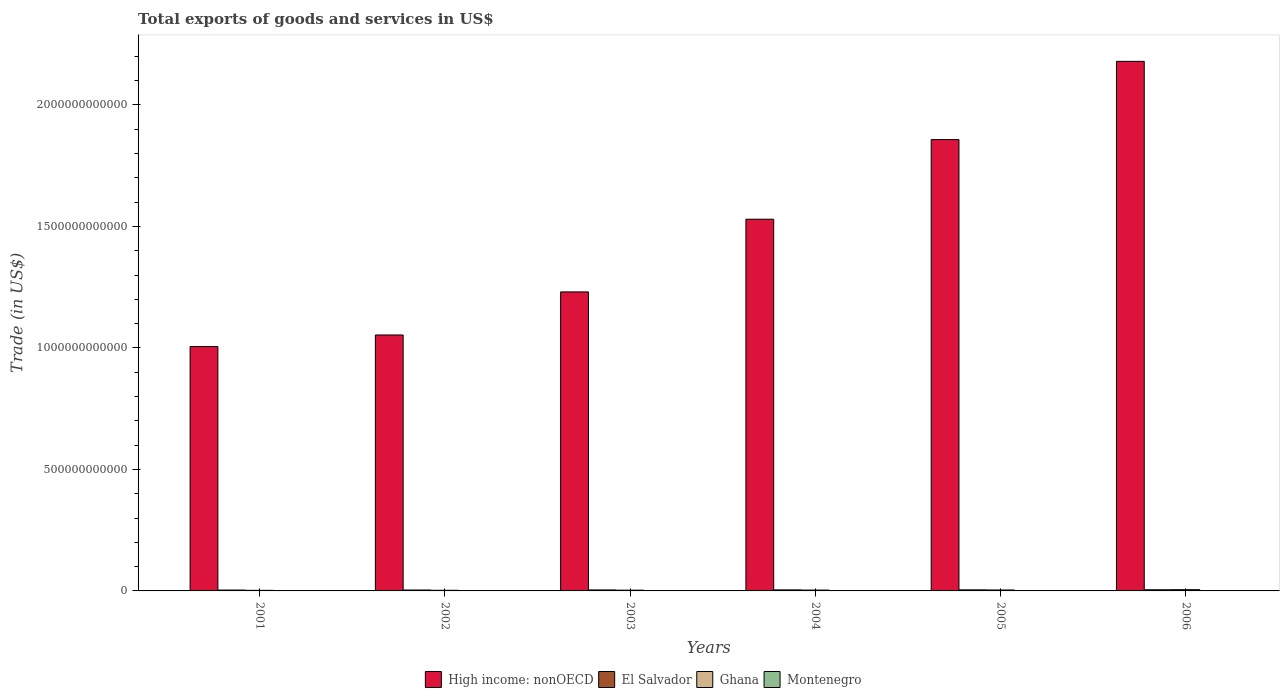How many different coloured bars are there?
Your answer should be compact. 4. Are the number of bars per tick equal to the number of legend labels?
Give a very brief answer. Yes. How many bars are there on the 1st tick from the right?
Keep it short and to the point. 4. What is the label of the 4th group of bars from the left?
Keep it short and to the point. 2004. What is the total exports of goods and services in Ghana in 2003?
Keep it short and to the point. 3.10e+09. Across all years, what is the maximum total exports of goods and services in Montenegro?
Your answer should be compact. 1.33e+09. Across all years, what is the minimum total exports of goods and services in High income: nonOECD?
Provide a succinct answer. 1.01e+12. What is the total total exports of goods and services in High income: nonOECD in the graph?
Provide a short and direct response. 8.86e+12. What is the difference between the total exports of goods and services in El Salvador in 2004 and that in 2006?
Give a very brief answer. -5.05e+08. What is the difference between the total exports of goods and services in El Salvador in 2006 and the total exports of goods and services in High income: nonOECD in 2002?
Give a very brief answer. -1.05e+12. What is the average total exports of goods and services in Montenegro per year?
Your answer should be compact. 7.68e+08. In the year 2003, what is the difference between the total exports of goods and services in High income: nonOECD and total exports of goods and services in Ghana?
Your answer should be compact. 1.23e+12. What is the ratio of the total exports of goods and services in Ghana in 2002 to that in 2004?
Provide a short and direct response. 0.75. What is the difference between the highest and the second highest total exports of goods and services in Ghana?
Keep it short and to the point. 1.23e+09. What is the difference between the highest and the lowest total exports of goods and services in Montenegro?
Provide a short and direct response. 8.85e+08. Is the sum of the total exports of goods and services in High income: nonOECD in 2003 and 2005 greater than the maximum total exports of goods and services in Montenegro across all years?
Ensure brevity in your answer.  Yes. What does the 1st bar from the left in 2003 represents?
Ensure brevity in your answer.  High income: nonOECD. What does the 4th bar from the right in 2004 represents?
Make the answer very short. High income: nonOECD. Is it the case that in every year, the sum of the total exports of goods and services in High income: nonOECD and total exports of goods and services in Montenegro is greater than the total exports of goods and services in Ghana?
Offer a very short reply. Yes. How many bars are there?
Keep it short and to the point. 24. Are all the bars in the graph horizontal?
Offer a terse response. No. What is the difference between two consecutive major ticks on the Y-axis?
Provide a succinct answer. 5.00e+11. Are the values on the major ticks of Y-axis written in scientific E-notation?
Make the answer very short. No. Does the graph contain any zero values?
Offer a very short reply. No. Does the graph contain grids?
Offer a terse response. No. How many legend labels are there?
Your response must be concise. 4. What is the title of the graph?
Make the answer very short. Total exports of goods and services in US$. What is the label or title of the Y-axis?
Your response must be concise. Trade (in US$). What is the Trade (in US$) of High income: nonOECD in 2001?
Your response must be concise. 1.01e+12. What is the Trade (in US$) in El Salvador in 2001?
Make the answer very short. 3.57e+09. What is the Trade (in US$) in Ghana in 2001?
Your answer should be very brief. 2.40e+09. What is the Trade (in US$) of Montenegro in 2001?
Your response must be concise. 4.46e+08. What is the Trade (in US$) in High income: nonOECD in 2002?
Offer a terse response. 1.05e+12. What is the Trade (in US$) in El Salvador in 2002?
Keep it short and to the point. 3.77e+09. What is the Trade (in US$) of Ghana in 2002?
Offer a terse response. 2.63e+09. What is the Trade (in US$) of Montenegro in 2002?
Provide a succinct answer. 4.54e+08. What is the Trade (in US$) in High income: nonOECD in 2003?
Your response must be concise. 1.23e+12. What is the Trade (in US$) of El Salvador in 2003?
Your answer should be compact. 4.07e+09. What is the Trade (in US$) of Ghana in 2003?
Ensure brevity in your answer.  3.10e+09. What is the Trade (in US$) in Montenegro in 2003?
Keep it short and to the point. 5.23e+08. What is the Trade (in US$) in High income: nonOECD in 2004?
Make the answer very short. 1.53e+12. What is the Trade (in US$) in El Salvador in 2004?
Provide a succinct answer. 4.26e+09. What is the Trade (in US$) in Ghana in 2004?
Offer a terse response. 3.49e+09. What is the Trade (in US$) in Montenegro in 2004?
Your response must be concise. 8.71e+08. What is the Trade (in US$) of High income: nonOECD in 2005?
Ensure brevity in your answer.  1.86e+12. What is the Trade (in US$) of El Salvador in 2005?
Your answer should be compact. 4.38e+09. What is the Trade (in US$) of Ghana in 2005?
Your answer should be compact. 3.91e+09. What is the Trade (in US$) of Montenegro in 2005?
Your response must be concise. 9.83e+08. What is the Trade (in US$) in High income: nonOECD in 2006?
Your answer should be compact. 2.18e+12. What is the Trade (in US$) of El Salvador in 2006?
Keep it short and to the point. 4.76e+09. What is the Trade (in US$) in Ghana in 2006?
Keep it short and to the point. 5.14e+09. What is the Trade (in US$) in Montenegro in 2006?
Provide a short and direct response. 1.33e+09. Across all years, what is the maximum Trade (in US$) of High income: nonOECD?
Give a very brief answer. 2.18e+12. Across all years, what is the maximum Trade (in US$) in El Salvador?
Offer a very short reply. 4.76e+09. Across all years, what is the maximum Trade (in US$) in Ghana?
Offer a terse response. 5.14e+09. Across all years, what is the maximum Trade (in US$) in Montenegro?
Give a very brief answer. 1.33e+09. Across all years, what is the minimum Trade (in US$) of High income: nonOECD?
Your answer should be very brief. 1.01e+12. Across all years, what is the minimum Trade (in US$) of El Salvador?
Your answer should be very brief. 3.57e+09. Across all years, what is the minimum Trade (in US$) of Ghana?
Offer a very short reply. 2.40e+09. Across all years, what is the minimum Trade (in US$) in Montenegro?
Make the answer very short. 4.46e+08. What is the total Trade (in US$) of High income: nonOECD in the graph?
Keep it short and to the point. 8.86e+12. What is the total Trade (in US$) in El Salvador in the graph?
Offer a terse response. 2.48e+1. What is the total Trade (in US$) in Ghana in the graph?
Your answer should be compact. 2.07e+1. What is the total Trade (in US$) of Montenegro in the graph?
Offer a very short reply. 4.61e+09. What is the difference between the Trade (in US$) in High income: nonOECD in 2001 and that in 2002?
Ensure brevity in your answer.  -4.76e+1. What is the difference between the Trade (in US$) of El Salvador in 2001 and that in 2002?
Make the answer very short. -2.04e+08. What is the difference between the Trade (in US$) of Ghana in 2001 and that in 2002?
Your answer should be very brief. -2.24e+08. What is the difference between the Trade (in US$) of Montenegro in 2001 and that in 2002?
Keep it short and to the point. -8.56e+06. What is the difference between the Trade (in US$) in High income: nonOECD in 2001 and that in 2003?
Offer a terse response. -2.25e+11. What is the difference between the Trade (in US$) of El Salvador in 2001 and that in 2003?
Give a very brief answer. -5.05e+08. What is the difference between the Trade (in US$) of Ghana in 2001 and that in 2003?
Offer a very short reply. -7.01e+08. What is the difference between the Trade (in US$) in Montenegro in 2001 and that in 2003?
Provide a succinct answer. -7.71e+07. What is the difference between the Trade (in US$) of High income: nonOECD in 2001 and that in 2004?
Provide a succinct answer. -5.24e+11. What is the difference between the Trade (in US$) in El Salvador in 2001 and that in 2004?
Offer a terse response. -6.91e+08. What is the difference between the Trade (in US$) of Ghana in 2001 and that in 2004?
Ensure brevity in your answer.  -1.09e+09. What is the difference between the Trade (in US$) in Montenegro in 2001 and that in 2004?
Make the answer very short. -4.26e+08. What is the difference between the Trade (in US$) in High income: nonOECD in 2001 and that in 2005?
Your answer should be very brief. -8.52e+11. What is the difference between the Trade (in US$) in El Salvador in 2001 and that in 2005?
Your answer should be compact. -8.15e+08. What is the difference between the Trade (in US$) in Ghana in 2001 and that in 2005?
Provide a short and direct response. -1.51e+09. What is the difference between the Trade (in US$) of Montenegro in 2001 and that in 2005?
Offer a very short reply. -5.37e+08. What is the difference between the Trade (in US$) of High income: nonOECD in 2001 and that in 2006?
Your response must be concise. -1.17e+12. What is the difference between the Trade (in US$) in El Salvador in 2001 and that in 2006?
Your response must be concise. -1.20e+09. What is the difference between the Trade (in US$) of Ghana in 2001 and that in 2006?
Offer a very short reply. -2.74e+09. What is the difference between the Trade (in US$) of Montenegro in 2001 and that in 2006?
Offer a terse response. -8.85e+08. What is the difference between the Trade (in US$) of High income: nonOECD in 2002 and that in 2003?
Offer a terse response. -1.77e+11. What is the difference between the Trade (in US$) of El Salvador in 2002 and that in 2003?
Your answer should be very brief. -3.01e+08. What is the difference between the Trade (in US$) in Ghana in 2002 and that in 2003?
Offer a very short reply. -4.77e+08. What is the difference between the Trade (in US$) of Montenegro in 2002 and that in 2003?
Your answer should be very brief. -6.85e+07. What is the difference between the Trade (in US$) in High income: nonOECD in 2002 and that in 2004?
Offer a very short reply. -4.76e+11. What is the difference between the Trade (in US$) in El Salvador in 2002 and that in 2004?
Make the answer very short. -4.87e+08. What is the difference between the Trade (in US$) of Ghana in 2002 and that in 2004?
Your answer should be compact. -8.63e+08. What is the difference between the Trade (in US$) of Montenegro in 2002 and that in 2004?
Offer a very short reply. -4.17e+08. What is the difference between the Trade (in US$) of High income: nonOECD in 2002 and that in 2005?
Provide a short and direct response. -8.04e+11. What is the difference between the Trade (in US$) in El Salvador in 2002 and that in 2005?
Offer a terse response. -6.11e+08. What is the difference between the Trade (in US$) in Ghana in 2002 and that in 2005?
Your answer should be very brief. -1.28e+09. What is the difference between the Trade (in US$) of Montenegro in 2002 and that in 2005?
Ensure brevity in your answer.  -5.29e+08. What is the difference between the Trade (in US$) of High income: nonOECD in 2002 and that in 2006?
Provide a short and direct response. -1.13e+12. What is the difference between the Trade (in US$) in El Salvador in 2002 and that in 2006?
Ensure brevity in your answer.  -9.92e+08. What is the difference between the Trade (in US$) in Ghana in 2002 and that in 2006?
Ensure brevity in your answer.  -2.51e+09. What is the difference between the Trade (in US$) in Montenegro in 2002 and that in 2006?
Provide a short and direct response. -8.77e+08. What is the difference between the Trade (in US$) of High income: nonOECD in 2003 and that in 2004?
Your answer should be very brief. -2.99e+11. What is the difference between the Trade (in US$) in El Salvador in 2003 and that in 2004?
Provide a succinct answer. -1.86e+08. What is the difference between the Trade (in US$) of Ghana in 2003 and that in 2004?
Your answer should be compact. -3.86e+08. What is the difference between the Trade (in US$) of Montenegro in 2003 and that in 2004?
Offer a terse response. -3.48e+08. What is the difference between the Trade (in US$) of High income: nonOECD in 2003 and that in 2005?
Give a very brief answer. -6.27e+11. What is the difference between the Trade (in US$) of El Salvador in 2003 and that in 2005?
Your response must be concise. -3.10e+08. What is the difference between the Trade (in US$) in Ghana in 2003 and that in 2005?
Your answer should be compact. -8.07e+08. What is the difference between the Trade (in US$) of Montenegro in 2003 and that in 2005?
Provide a short and direct response. -4.60e+08. What is the difference between the Trade (in US$) in High income: nonOECD in 2003 and that in 2006?
Provide a succinct answer. -9.49e+11. What is the difference between the Trade (in US$) of El Salvador in 2003 and that in 2006?
Offer a very short reply. -6.91e+08. What is the difference between the Trade (in US$) of Ghana in 2003 and that in 2006?
Your answer should be compact. -2.04e+09. What is the difference between the Trade (in US$) in Montenegro in 2003 and that in 2006?
Your response must be concise. -8.08e+08. What is the difference between the Trade (in US$) in High income: nonOECD in 2004 and that in 2005?
Offer a terse response. -3.28e+11. What is the difference between the Trade (in US$) in El Salvador in 2004 and that in 2005?
Your answer should be compact. -1.24e+08. What is the difference between the Trade (in US$) in Ghana in 2004 and that in 2005?
Your answer should be compact. -4.21e+08. What is the difference between the Trade (in US$) in Montenegro in 2004 and that in 2005?
Offer a terse response. -1.12e+08. What is the difference between the Trade (in US$) in High income: nonOECD in 2004 and that in 2006?
Provide a short and direct response. -6.50e+11. What is the difference between the Trade (in US$) of El Salvador in 2004 and that in 2006?
Give a very brief answer. -5.05e+08. What is the difference between the Trade (in US$) of Ghana in 2004 and that in 2006?
Your response must be concise. -1.65e+09. What is the difference between the Trade (in US$) in Montenegro in 2004 and that in 2006?
Your response must be concise. -4.60e+08. What is the difference between the Trade (in US$) in High income: nonOECD in 2005 and that in 2006?
Offer a terse response. -3.22e+11. What is the difference between the Trade (in US$) in El Salvador in 2005 and that in 2006?
Keep it short and to the point. -3.81e+08. What is the difference between the Trade (in US$) in Ghana in 2005 and that in 2006?
Ensure brevity in your answer.  -1.23e+09. What is the difference between the Trade (in US$) of Montenegro in 2005 and that in 2006?
Your answer should be compact. -3.48e+08. What is the difference between the Trade (in US$) in High income: nonOECD in 2001 and the Trade (in US$) in El Salvador in 2002?
Ensure brevity in your answer.  1.00e+12. What is the difference between the Trade (in US$) in High income: nonOECD in 2001 and the Trade (in US$) in Ghana in 2002?
Keep it short and to the point. 1.00e+12. What is the difference between the Trade (in US$) in High income: nonOECD in 2001 and the Trade (in US$) in Montenegro in 2002?
Your response must be concise. 1.01e+12. What is the difference between the Trade (in US$) in El Salvador in 2001 and the Trade (in US$) in Ghana in 2002?
Offer a terse response. 9.40e+08. What is the difference between the Trade (in US$) of El Salvador in 2001 and the Trade (in US$) of Montenegro in 2002?
Provide a succinct answer. 3.11e+09. What is the difference between the Trade (in US$) of Ghana in 2001 and the Trade (in US$) of Montenegro in 2002?
Offer a very short reply. 1.95e+09. What is the difference between the Trade (in US$) of High income: nonOECD in 2001 and the Trade (in US$) of El Salvador in 2003?
Your response must be concise. 1.00e+12. What is the difference between the Trade (in US$) in High income: nonOECD in 2001 and the Trade (in US$) in Ghana in 2003?
Ensure brevity in your answer.  1.00e+12. What is the difference between the Trade (in US$) in High income: nonOECD in 2001 and the Trade (in US$) in Montenegro in 2003?
Make the answer very short. 1.01e+12. What is the difference between the Trade (in US$) of El Salvador in 2001 and the Trade (in US$) of Ghana in 2003?
Keep it short and to the point. 4.63e+08. What is the difference between the Trade (in US$) of El Salvador in 2001 and the Trade (in US$) of Montenegro in 2003?
Give a very brief answer. 3.05e+09. What is the difference between the Trade (in US$) in Ghana in 2001 and the Trade (in US$) in Montenegro in 2003?
Give a very brief answer. 1.88e+09. What is the difference between the Trade (in US$) in High income: nonOECD in 2001 and the Trade (in US$) in El Salvador in 2004?
Keep it short and to the point. 1.00e+12. What is the difference between the Trade (in US$) in High income: nonOECD in 2001 and the Trade (in US$) in Ghana in 2004?
Give a very brief answer. 1.00e+12. What is the difference between the Trade (in US$) of High income: nonOECD in 2001 and the Trade (in US$) of Montenegro in 2004?
Provide a succinct answer. 1.00e+12. What is the difference between the Trade (in US$) in El Salvador in 2001 and the Trade (in US$) in Ghana in 2004?
Provide a short and direct response. 7.73e+07. What is the difference between the Trade (in US$) in El Salvador in 2001 and the Trade (in US$) in Montenegro in 2004?
Offer a very short reply. 2.70e+09. What is the difference between the Trade (in US$) of Ghana in 2001 and the Trade (in US$) of Montenegro in 2004?
Provide a succinct answer. 1.53e+09. What is the difference between the Trade (in US$) of High income: nonOECD in 2001 and the Trade (in US$) of El Salvador in 2005?
Your answer should be compact. 1.00e+12. What is the difference between the Trade (in US$) in High income: nonOECD in 2001 and the Trade (in US$) in Ghana in 2005?
Your answer should be very brief. 1.00e+12. What is the difference between the Trade (in US$) of High income: nonOECD in 2001 and the Trade (in US$) of Montenegro in 2005?
Offer a very short reply. 1.00e+12. What is the difference between the Trade (in US$) in El Salvador in 2001 and the Trade (in US$) in Ghana in 2005?
Give a very brief answer. -3.44e+08. What is the difference between the Trade (in US$) in El Salvador in 2001 and the Trade (in US$) in Montenegro in 2005?
Offer a terse response. 2.59e+09. What is the difference between the Trade (in US$) of Ghana in 2001 and the Trade (in US$) of Montenegro in 2005?
Ensure brevity in your answer.  1.42e+09. What is the difference between the Trade (in US$) in High income: nonOECD in 2001 and the Trade (in US$) in El Salvador in 2006?
Your response must be concise. 1.00e+12. What is the difference between the Trade (in US$) of High income: nonOECD in 2001 and the Trade (in US$) of Ghana in 2006?
Ensure brevity in your answer.  1.00e+12. What is the difference between the Trade (in US$) of High income: nonOECD in 2001 and the Trade (in US$) of Montenegro in 2006?
Make the answer very short. 1.00e+12. What is the difference between the Trade (in US$) in El Salvador in 2001 and the Trade (in US$) in Ghana in 2006?
Keep it short and to the point. -1.57e+09. What is the difference between the Trade (in US$) of El Salvador in 2001 and the Trade (in US$) of Montenegro in 2006?
Keep it short and to the point. 2.24e+09. What is the difference between the Trade (in US$) in Ghana in 2001 and the Trade (in US$) in Montenegro in 2006?
Offer a very short reply. 1.07e+09. What is the difference between the Trade (in US$) of High income: nonOECD in 2002 and the Trade (in US$) of El Salvador in 2003?
Your answer should be very brief. 1.05e+12. What is the difference between the Trade (in US$) of High income: nonOECD in 2002 and the Trade (in US$) of Ghana in 2003?
Your answer should be compact. 1.05e+12. What is the difference between the Trade (in US$) of High income: nonOECD in 2002 and the Trade (in US$) of Montenegro in 2003?
Give a very brief answer. 1.05e+12. What is the difference between the Trade (in US$) of El Salvador in 2002 and the Trade (in US$) of Ghana in 2003?
Ensure brevity in your answer.  6.67e+08. What is the difference between the Trade (in US$) of El Salvador in 2002 and the Trade (in US$) of Montenegro in 2003?
Offer a very short reply. 3.25e+09. What is the difference between the Trade (in US$) of Ghana in 2002 and the Trade (in US$) of Montenegro in 2003?
Offer a very short reply. 2.11e+09. What is the difference between the Trade (in US$) in High income: nonOECD in 2002 and the Trade (in US$) in El Salvador in 2004?
Make the answer very short. 1.05e+12. What is the difference between the Trade (in US$) in High income: nonOECD in 2002 and the Trade (in US$) in Ghana in 2004?
Keep it short and to the point. 1.05e+12. What is the difference between the Trade (in US$) in High income: nonOECD in 2002 and the Trade (in US$) in Montenegro in 2004?
Your answer should be compact. 1.05e+12. What is the difference between the Trade (in US$) in El Salvador in 2002 and the Trade (in US$) in Ghana in 2004?
Your answer should be compact. 2.82e+08. What is the difference between the Trade (in US$) in El Salvador in 2002 and the Trade (in US$) in Montenegro in 2004?
Offer a very short reply. 2.90e+09. What is the difference between the Trade (in US$) in Ghana in 2002 and the Trade (in US$) in Montenegro in 2004?
Your answer should be compact. 1.76e+09. What is the difference between the Trade (in US$) in High income: nonOECD in 2002 and the Trade (in US$) in El Salvador in 2005?
Ensure brevity in your answer.  1.05e+12. What is the difference between the Trade (in US$) in High income: nonOECD in 2002 and the Trade (in US$) in Ghana in 2005?
Make the answer very short. 1.05e+12. What is the difference between the Trade (in US$) in High income: nonOECD in 2002 and the Trade (in US$) in Montenegro in 2005?
Make the answer very short. 1.05e+12. What is the difference between the Trade (in US$) of El Salvador in 2002 and the Trade (in US$) of Ghana in 2005?
Give a very brief answer. -1.39e+08. What is the difference between the Trade (in US$) in El Salvador in 2002 and the Trade (in US$) in Montenegro in 2005?
Keep it short and to the point. 2.79e+09. What is the difference between the Trade (in US$) in Ghana in 2002 and the Trade (in US$) in Montenegro in 2005?
Offer a terse response. 1.64e+09. What is the difference between the Trade (in US$) in High income: nonOECD in 2002 and the Trade (in US$) in El Salvador in 2006?
Make the answer very short. 1.05e+12. What is the difference between the Trade (in US$) of High income: nonOECD in 2002 and the Trade (in US$) of Ghana in 2006?
Provide a succinct answer. 1.05e+12. What is the difference between the Trade (in US$) in High income: nonOECD in 2002 and the Trade (in US$) in Montenegro in 2006?
Offer a very short reply. 1.05e+12. What is the difference between the Trade (in US$) in El Salvador in 2002 and the Trade (in US$) in Ghana in 2006?
Ensure brevity in your answer.  -1.37e+09. What is the difference between the Trade (in US$) in El Salvador in 2002 and the Trade (in US$) in Montenegro in 2006?
Offer a terse response. 2.44e+09. What is the difference between the Trade (in US$) in Ghana in 2002 and the Trade (in US$) in Montenegro in 2006?
Make the answer very short. 1.30e+09. What is the difference between the Trade (in US$) in High income: nonOECD in 2003 and the Trade (in US$) in El Salvador in 2004?
Offer a terse response. 1.23e+12. What is the difference between the Trade (in US$) in High income: nonOECD in 2003 and the Trade (in US$) in Ghana in 2004?
Provide a short and direct response. 1.23e+12. What is the difference between the Trade (in US$) of High income: nonOECD in 2003 and the Trade (in US$) of Montenegro in 2004?
Offer a very short reply. 1.23e+12. What is the difference between the Trade (in US$) in El Salvador in 2003 and the Trade (in US$) in Ghana in 2004?
Provide a succinct answer. 5.82e+08. What is the difference between the Trade (in US$) of El Salvador in 2003 and the Trade (in US$) of Montenegro in 2004?
Provide a succinct answer. 3.20e+09. What is the difference between the Trade (in US$) of Ghana in 2003 and the Trade (in US$) of Montenegro in 2004?
Give a very brief answer. 2.23e+09. What is the difference between the Trade (in US$) in High income: nonOECD in 2003 and the Trade (in US$) in El Salvador in 2005?
Your answer should be very brief. 1.23e+12. What is the difference between the Trade (in US$) in High income: nonOECD in 2003 and the Trade (in US$) in Ghana in 2005?
Your response must be concise. 1.23e+12. What is the difference between the Trade (in US$) in High income: nonOECD in 2003 and the Trade (in US$) in Montenegro in 2005?
Your answer should be very brief. 1.23e+12. What is the difference between the Trade (in US$) of El Salvador in 2003 and the Trade (in US$) of Ghana in 2005?
Provide a succinct answer. 1.61e+08. What is the difference between the Trade (in US$) in El Salvador in 2003 and the Trade (in US$) in Montenegro in 2005?
Make the answer very short. 3.09e+09. What is the difference between the Trade (in US$) in Ghana in 2003 and the Trade (in US$) in Montenegro in 2005?
Provide a short and direct response. 2.12e+09. What is the difference between the Trade (in US$) in High income: nonOECD in 2003 and the Trade (in US$) in El Salvador in 2006?
Offer a very short reply. 1.23e+12. What is the difference between the Trade (in US$) of High income: nonOECD in 2003 and the Trade (in US$) of Ghana in 2006?
Your answer should be very brief. 1.23e+12. What is the difference between the Trade (in US$) of High income: nonOECD in 2003 and the Trade (in US$) of Montenegro in 2006?
Provide a short and direct response. 1.23e+12. What is the difference between the Trade (in US$) in El Salvador in 2003 and the Trade (in US$) in Ghana in 2006?
Give a very brief answer. -1.07e+09. What is the difference between the Trade (in US$) of El Salvador in 2003 and the Trade (in US$) of Montenegro in 2006?
Your answer should be compact. 2.74e+09. What is the difference between the Trade (in US$) of Ghana in 2003 and the Trade (in US$) of Montenegro in 2006?
Your answer should be compact. 1.77e+09. What is the difference between the Trade (in US$) in High income: nonOECD in 2004 and the Trade (in US$) in El Salvador in 2005?
Give a very brief answer. 1.53e+12. What is the difference between the Trade (in US$) of High income: nonOECD in 2004 and the Trade (in US$) of Ghana in 2005?
Keep it short and to the point. 1.53e+12. What is the difference between the Trade (in US$) of High income: nonOECD in 2004 and the Trade (in US$) of Montenegro in 2005?
Your answer should be very brief. 1.53e+12. What is the difference between the Trade (in US$) in El Salvador in 2004 and the Trade (in US$) in Ghana in 2005?
Your answer should be compact. 3.47e+08. What is the difference between the Trade (in US$) of El Salvador in 2004 and the Trade (in US$) of Montenegro in 2005?
Keep it short and to the point. 3.28e+09. What is the difference between the Trade (in US$) of Ghana in 2004 and the Trade (in US$) of Montenegro in 2005?
Provide a succinct answer. 2.51e+09. What is the difference between the Trade (in US$) in High income: nonOECD in 2004 and the Trade (in US$) in El Salvador in 2006?
Provide a succinct answer. 1.52e+12. What is the difference between the Trade (in US$) in High income: nonOECD in 2004 and the Trade (in US$) in Ghana in 2006?
Keep it short and to the point. 1.52e+12. What is the difference between the Trade (in US$) of High income: nonOECD in 2004 and the Trade (in US$) of Montenegro in 2006?
Offer a very short reply. 1.53e+12. What is the difference between the Trade (in US$) of El Salvador in 2004 and the Trade (in US$) of Ghana in 2006?
Keep it short and to the point. -8.83e+08. What is the difference between the Trade (in US$) in El Salvador in 2004 and the Trade (in US$) in Montenegro in 2006?
Offer a very short reply. 2.93e+09. What is the difference between the Trade (in US$) in Ghana in 2004 and the Trade (in US$) in Montenegro in 2006?
Provide a succinct answer. 2.16e+09. What is the difference between the Trade (in US$) in High income: nonOECD in 2005 and the Trade (in US$) in El Salvador in 2006?
Your answer should be very brief. 1.85e+12. What is the difference between the Trade (in US$) in High income: nonOECD in 2005 and the Trade (in US$) in Ghana in 2006?
Give a very brief answer. 1.85e+12. What is the difference between the Trade (in US$) of High income: nonOECD in 2005 and the Trade (in US$) of Montenegro in 2006?
Give a very brief answer. 1.86e+12. What is the difference between the Trade (in US$) in El Salvador in 2005 and the Trade (in US$) in Ghana in 2006?
Give a very brief answer. -7.59e+08. What is the difference between the Trade (in US$) of El Salvador in 2005 and the Trade (in US$) of Montenegro in 2006?
Offer a very short reply. 3.05e+09. What is the difference between the Trade (in US$) in Ghana in 2005 and the Trade (in US$) in Montenegro in 2006?
Ensure brevity in your answer.  2.58e+09. What is the average Trade (in US$) of High income: nonOECD per year?
Make the answer very short. 1.48e+12. What is the average Trade (in US$) of El Salvador per year?
Your answer should be very brief. 4.14e+09. What is the average Trade (in US$) of Ghana per year?
Provide a succinct answer. 3.45e+09. What is the average Trade (in US$) in Montenegro per year?
Your response must be concise. 7.68e+08. In the year 2001, what is the difference between the Trade (in US$) of High income: nonOECD and Trade (in US$) of El Salvador?
Give a very brief answer. 1.00e+12. In the year 2001, what is the difference between the Trade (in US$) in High income: nonOECD and Trade (in US$) in Ghana?
Make the answer very short. 1.00e+12. In the year 2001, what is the difference between the Trade (in US$) of High income: nonOECD and Trade (in US$) of Montenegro?
Your answer should be very brief. 1.01e+12. In the year 2001, what is the difference between the Trade (in US$) in El Salvador and Trade (in US$) in Ghana?
Your answer should be very brief. 1.16e+09. In the year 2001, what is the difference between the Trade (in US$) of El Salvador and Trade (in US$) of Montenegro?
Provide a succinct answer. 3.12e+09. In the year 2001, what is the difference between the Trade (in US$) in Ghana and Trade (in US$) in Montenegro?
Ensure brevity in your answer.  1.96e+09. In the year 2002, what is the difference between the Trade (in US$) in High income: nonOECD and Trade (in US$) in El Salvador?
Your answer should be compact. 1.05e+12. In the year 2002, what is the difference between the Trade (in US$) of High income: nonOECD and Trade (in US$) of Ghana?
Offer a very short reply. 1.05e+12. In the year 2002, what is the difference between the Trade (in US$) of High income: nonOECD and Trade (in US$) of Montenegro?
Make the answer very short. 1.05e+12. In the year 2002, what is the difference between the Trade (in US$) of El Salvador and Trade (in US$) of Ghana?
Give a very brief answer. 1.14e+09. In the year 2002, what is the difference between the Trade (in US$) of El Salvador and Trade (in US$) of Montenegro?
Offer a very short reply. 3.32e+09. In the year 2002, what is the difference between the Trade (in US$) in Ghana and Trade (in US$) in Montenegro?
Provide a short and direct response. 2.17e+09. In the year 2003, what is the difference between the Trade (in US$) in High income: nonOECD and Trade (in US$) in El Salvador?
Ensure brevity in your answer.  1.23e+12. In the year 2003, what is the difference between the Trade (in US$) in High income: nonOECD and Trade (in US$) in Ghana?
Keep it short and to the point. 1.23e+12. In the year 2003, what is the difference between the Trade (in US$) in High income: nonOECD and Trade (in US$) in Montenegro?
Ensure brevity in your answer.  1.23e+12. In the year 2003, what is the difference between the Trade (in US$) in El Salvador and Trade (in US$) in Ghana?
Provide a succinct answer. 9.68e+08. In the year 2003, what is the difference between the Trade (in US$) in El Salvador and Trade (in US$) in Montenegro?
Give a very brief answer. 3.55e+09. In the year 2003, what is the difference between the Trade (in US$) of Ghana and Trade (in US$) of Montenegro?
Your answer should be very brief. 2.58e+09. In the year 2004, what is the difference between the Trade (in US$) of High income: nonOECD and Trade (in US$) of El Salvador?
Make the answer very short. 1.53e+12. In the year 2004, what is the difference between the Trade (in US$) in High income: nonOECD and Trade (in US$) in Ghana?
Provide a short and direct response. 1.53e+12. In the year 2004, what is the difference between the Trade (in US$) in High income: nonOECD and Trade (in US$) in Montenegro?
Offer a terse response. 1.53e+12. In the year 2004, what is the difference between the Trade (in US$) in El Salvador and Trade (in US$) in Ghana?
Your answer should be very brief. 7.68e+08. In the year 2004, what is the difference between the Trade (in US$) of El Salvador and Trade (in US$) of Montenegro?
Your answer should be compact. 3.39e+09. In the year 2004, what is the difference between the Trade (in US$) in Ghana and Trade (in US$) in Montenegro?
Your answer should be compact. 2.62e+09. In the year 2005, what is the difference between the Trade (in US$) of High income: nonOECD and Trade (in US$) of El Salvador?
Keep it short and to the point. 1.85e+12. In the year 2005, what is the difference between the Trade (in US$) in High income: nonOECD and Trade (in US$) in Ghana?
Your answer should be compact. 1.85e+12. In the year 2005, what is the difference between the Trade (in US$) of High income: nonOECD and Trade (in US$) of Montenegro?
Keep it short and to the point. 1.86e+12. In the year 2005, what is the difference between the Trade (in US$) in El Salvador and Trade (in US$) in Ghana?
Your answer should be compact. 4.71e+08. In the year 2005, what is the difference between the Trade (in US$) in El Salvador and Trade (in US$) in Montenegro?
Ensure brevity in your answer.  3.40e+09. In the year 2005, what is the difference between the Trade (in US$) of Ghana and Trade (in US$) of Montenegro?
Offer a terse response. 2.93e+09. In the year 2006, what is the difference between the Trade (in US$) of High income: nonOECD and Trade (in US$) of El Salvador?
Provide a succinct answer. 2.17e+12. In the year 2006, what is the difference between the Trade (in US$) in High income: nonOECD and Trade (in US$) in Ghana?
Provide a succinct answer. 2.17e+12. In the year 2006, what is the difference between the Trade (in US$) in High income: nonOECD and Trade (in US$) in Montenegro?
Give a very brief answer. 2.18e+12. In the year 2006, what is the difference between the Trade (in US$) of El Salvador and Trade (in US$) of Ghana?
Provide a short and direct response. -3.77e+08. In the year 2006, what is the difference between the Trade (in US$) in El Salvador and Trade (in US$) in Montenegro?
Make the answer very short. 3.43e+09. In the year 2006, what is the difference between the Trade (in US$) in Ghana and Trade (in US$) in Montenegro?
Provide a succinct answer. 3.81e+09. What is the ratio of the Trade (in US$) in High income: nonOECD in 2001 to that in 2002?
Your answer should be very brief. 0.95. What is the ratio of the Trade (in US$) of El Salvador in 2001 to that in 2002?
Provide a short and direct response. 0.95. What is the ratio of the Trade (in US$) of Ghana in 2001 to that in 2002?
Offer a very short reply. 0.91. What is the ratio of the Trade (in US$) of Montenegro in 2001 to that in 2002?
Provide a short and direct response. 0.98. What is the ratio of the Trade (in US$) in High income: nonOECD in 2001 to that in 2003?
Provide a short and direct response. 0.82. What is the ratio of the Trade (in US$) in El Salvador in 2001 to that in 2003?
Offer a terse response. 0.88. What is the ratio of the Trade (in US$) of Ghana in 2001 to that in 2003?
Offer a terse response. 0.77. What is the ratio of the Trade (in US$) in Montenegro in 2001 to that in 2003?
Offer a terse response. 0.85. What is the ratio of the Trade (in US$) of High income: nonOECD in 2001 to that in 2004?
Provide a short and direct response. 0.66. What is the ratio of the Trade (in US$) of El Salvador in 2001 to that in 2004?
Make the answer very short. 0.84. What is the ratio of the Trade (in US$) in Ghana in 2001 to that in 2004?
Offer a very short reply. 0.69. What is the ratio of the Trade (in US$) in Montenegro in 2001 to that in 2004?
Keep it short and to the point. 0.51. What is the ratio of the Trade (in US$) of High income: nonOECD in 2001 to that in 2005?
Your answer should be very brief. 0.54. What is the ratio of the Trade (in US$) in El Salvador in 2001 to that in 2005?
Keep it short and to the point. 0.81. What is the ratio of the Trade (in US$) in Ghana in 2001 to that in 2005?
Ensure brevity in your answer.  0.61. What is the ratio of the Trade (in US$) in Montenegro in 2001 to that in 2005?
Keep it short and to the point. 0.45. What is the ratio of the Trade (in US$) of High income: nonOECD in 2001 to that in 2006?
Give a very brief answer. 0.46. What is the ratio of the Trade (in US$) in El Salvador in 2001 to that in 2006?
Your response must be concise. 0.75. What is the ratio of the Trade (in US$) of Ghana in 2001 to that in 2006?
Ensure brevity in your answer.  0.47. What is the ratio of the Trade (in US$) of Montenegro in 2001 to that in 2006?
Your answer should be compact. 0.33. What is the ratio of the Trade (in US$) in High income: nonOECD in 2002 to that in 2003?
Make the answer very short. 0.86. What is the ratio of the Trade (in US$) of El Salvador in 2002 to that in 2003?
Provide a succinct answer. 0.93. What is the ratio of the Trade (in US$) of Ghana in 2002 to that in 2003?
Your answer should be very brief. 0.85. What is the ratio of the Trade (in US$) of Montenegro in 2002 to that in 2003?
Your answer should be very brief. 0.87. What is the ratio of the Trade (in US$) in High income: nonOECD in 2002 to that in 2004?
Your response must be concise. 0.69. What is the ratio of the Trade (in US$) of El Salvador in 2002 to that in 2004?
Give a very brief answer. 0.89. What is the ratio of the Trade (in US$) in Ghana in 2002 to that in 2004?
Ensure brevity in your answer.  0.75. What is the ratio of the Trade (in US$) in Montenegro in 2002 to that in 2004?
Your answer should be compact. 0.52. What is the ratio of the Trade (in US$) of High income: nonOECD in 2002 to that in 2005?
Your response must be concise. 0.57. What is the ratio of the Trade (in US$) in El Salvador in 2002 to that in 2005?
Offer a terse response. 0.86. What is the ratio of the Trade (in US$) of Ghana in 2002 to that in 2005?
Provide a succinct answer. 0.67. What is the ratio of the Trade (in US$) in Montenegro in 2002 to that in 2005?
Provide a succinct answer. 0.46. What is the ratio of the Trade (in US$) of High income: nonOECD in 2002 to that in 2006?
Your answer should be very brief. 0.48. What is the ratio of the Trade (in US$) of El Salvador in 2002 to that in 2006?
Keep it short and to the point. 0.79. What is the ratio of the Trade (in US$) of Ghana in 2002 to that in 2006?
Offer a very short reply. 0.51. What is the ratio of the Trade (in US$) in Montenegro in 2002 to that in 2006?
Provide a succinct answer. 0.34. What is the ratio of the Trade (in US$) of High income: nonOECD in 2003 to that in 2004?
Your answer should be very brief. 0.8. What is the ratio of the Trade (in US$) of El Salvador in 2003 to that in 2004?
Keep it short and to the point. 0.96. What is the ratio of the Trade (in US$) of Ghana in 2003 to that in 2004?
Your response must be concise. 0.89. What is the ratio of the Trade (in US$) of High income: nonOECD in 2003 to that in 2005?
Your response must be concise. 0.66. What is the ratio of the Trade (in US$) in El Salvador in 2003 to that in 2005?
Make the answer very short. 0.93. What is the ratio of the Trade (in US$) of Ghana in 2003 to that in 2005?
Provide a short and direct response. 0.79. What is the ratio of the Trade (in US$) in Montenegro in 2003 to that in 2005?
Offer a very short reply. 0.53. What is the ratio of the Trade (in US$) of High income: nonOECD in 2003 to that in 2006?
Offer a very short reply. 0.56. What is the ratio of the Trade (in US$) in El Salvador in 2003 to that in 2006?
Give a very brief answer. 0.85. What is the ratio of the Trade (in US$) in Ghana in 2003 to that in 2006?
Offer a terse response. 0.6. What is the ratio of the Trade (in US$) of Montenegro in 2003 to that in 2006?
Provide a short and direct response. 0.39. What is the ratio of the Trade (in US$) in High income: nonOECD in 2004 to that in 2005?
Provide a short and direct response. 0.82. What is the ratio of the Trade (in US$) in El Salvador in 2004 to that in 2005?
Keep it short and to the point. 0.97. What is the ratio of the Trade (in US$) of Ghana in 2004 to that in 2005?
Your answer should be compact. 0.89. What is the ratio of the Trade (in US$) in Montenegro in 2004 to that in 2005?
Your answer should be compact. 0.89. What is the ratio of the Trade (in US$) in High income: nonOECD in 2004 to that in 2006?
Offer a terse response. 0.7. What is the ratio of the Trade (in US$) in El Salvador in 2004 to that in 2006?
Ensure brevity in your answer.  0.89. What is the ratio of the Trade (in US$) in Ghana in 2004 to that in 2006?
Your answer should be very brief. 0.68. What is the ratio of the Trade (in US$) of Montenegro in 2004 to that in 2006?
Offer a very short reply. 0.65. What is the ratio of the Trade (in US$) of High income: nonOECD in 2005 to that in 2006?
Provide a succinct answer. 0.85. What is the ratio of the Trade (in US$) of El Salvador in 2005 to that in 2006?
Offer a very short reply. 0.92. What is the ratio of the Trade (in US$) of Ghana in 2005 to that in 2006?
Keep it short and to the point. 0.76. What is the ratio of the Trade (in US$) in Montenegro in 2005 to that in 2006?
Your answer should be compact. 0.74. What is the difference between the highest and the second highest Trade (in US$) in High income: nonOECD?
Offer a very short reply. 3.22e+11. What is the difference between the highest and the second highest Trade (in US$) of El Salvador?
Keep it short and to the point. 3.81e+08. What is the difference between the highest and the second highest Trade (in US$) in Ghana?
Keep it short and to the point. 1.23e+09. What is the difference between the highest and the second highest Trade (in US$) of Montenegro?
Provide a short and direct response. 3.48e+08. What is the difference between the highest and the lowest Trade (in US$) of High income: nonOECD?
Provide a succinct answer. 1.17e+12. What is the difference between the highest and the lowest Trade (in US$) of El Salvador?
Your answer should be compact. 1.20e+09. What is the difference between the highest and the lowest Trade (in US$) in Ghana?
Ensure brevity in your answer.  2.74e+09. What is the difference between the highest and the lowest Trade (in US$) of Montenegro?
Offer a terse response. 8.85e+08. 